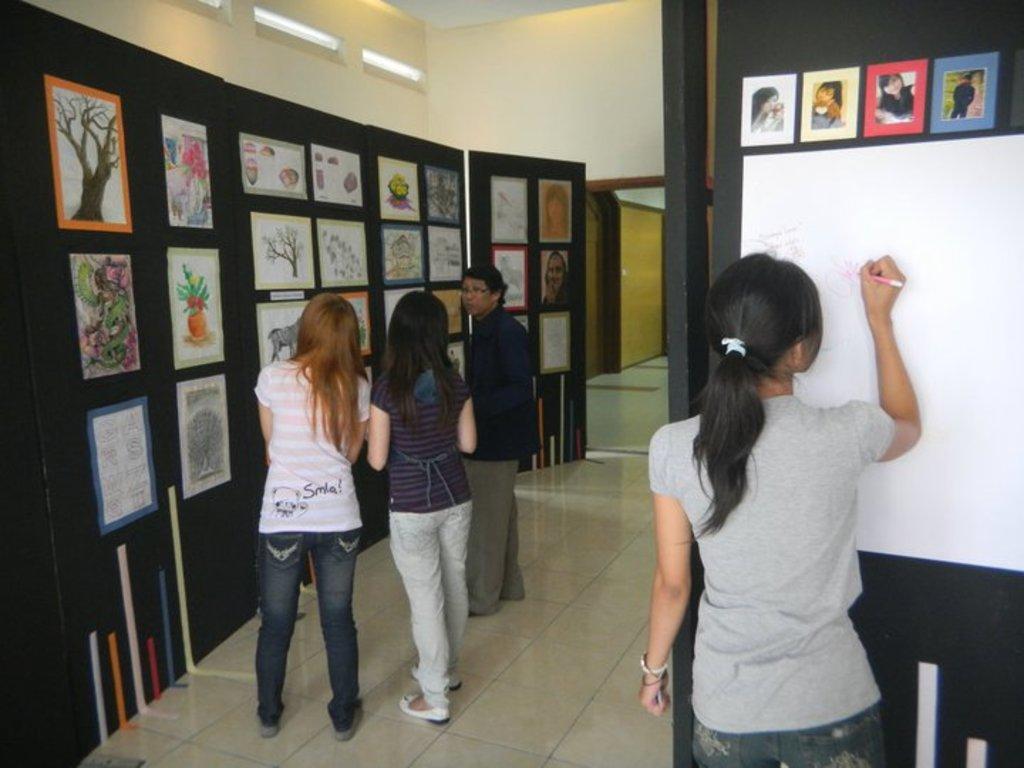In one or two sentences, can you explain what this image depicts? As we can see in the image there is a wall, lights, papers, drawing and few people here and there. 